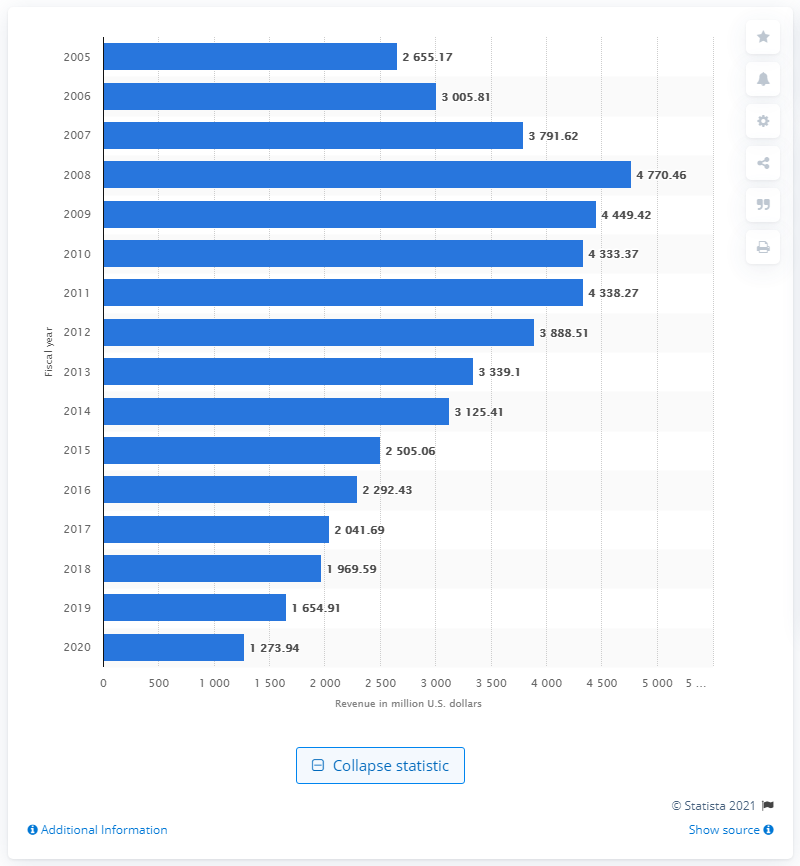Outline some significant characteristics in this image. The global revenue of the ESPRIT brand in dollars for fiscal year 2019/2020 was 1,273.94. 